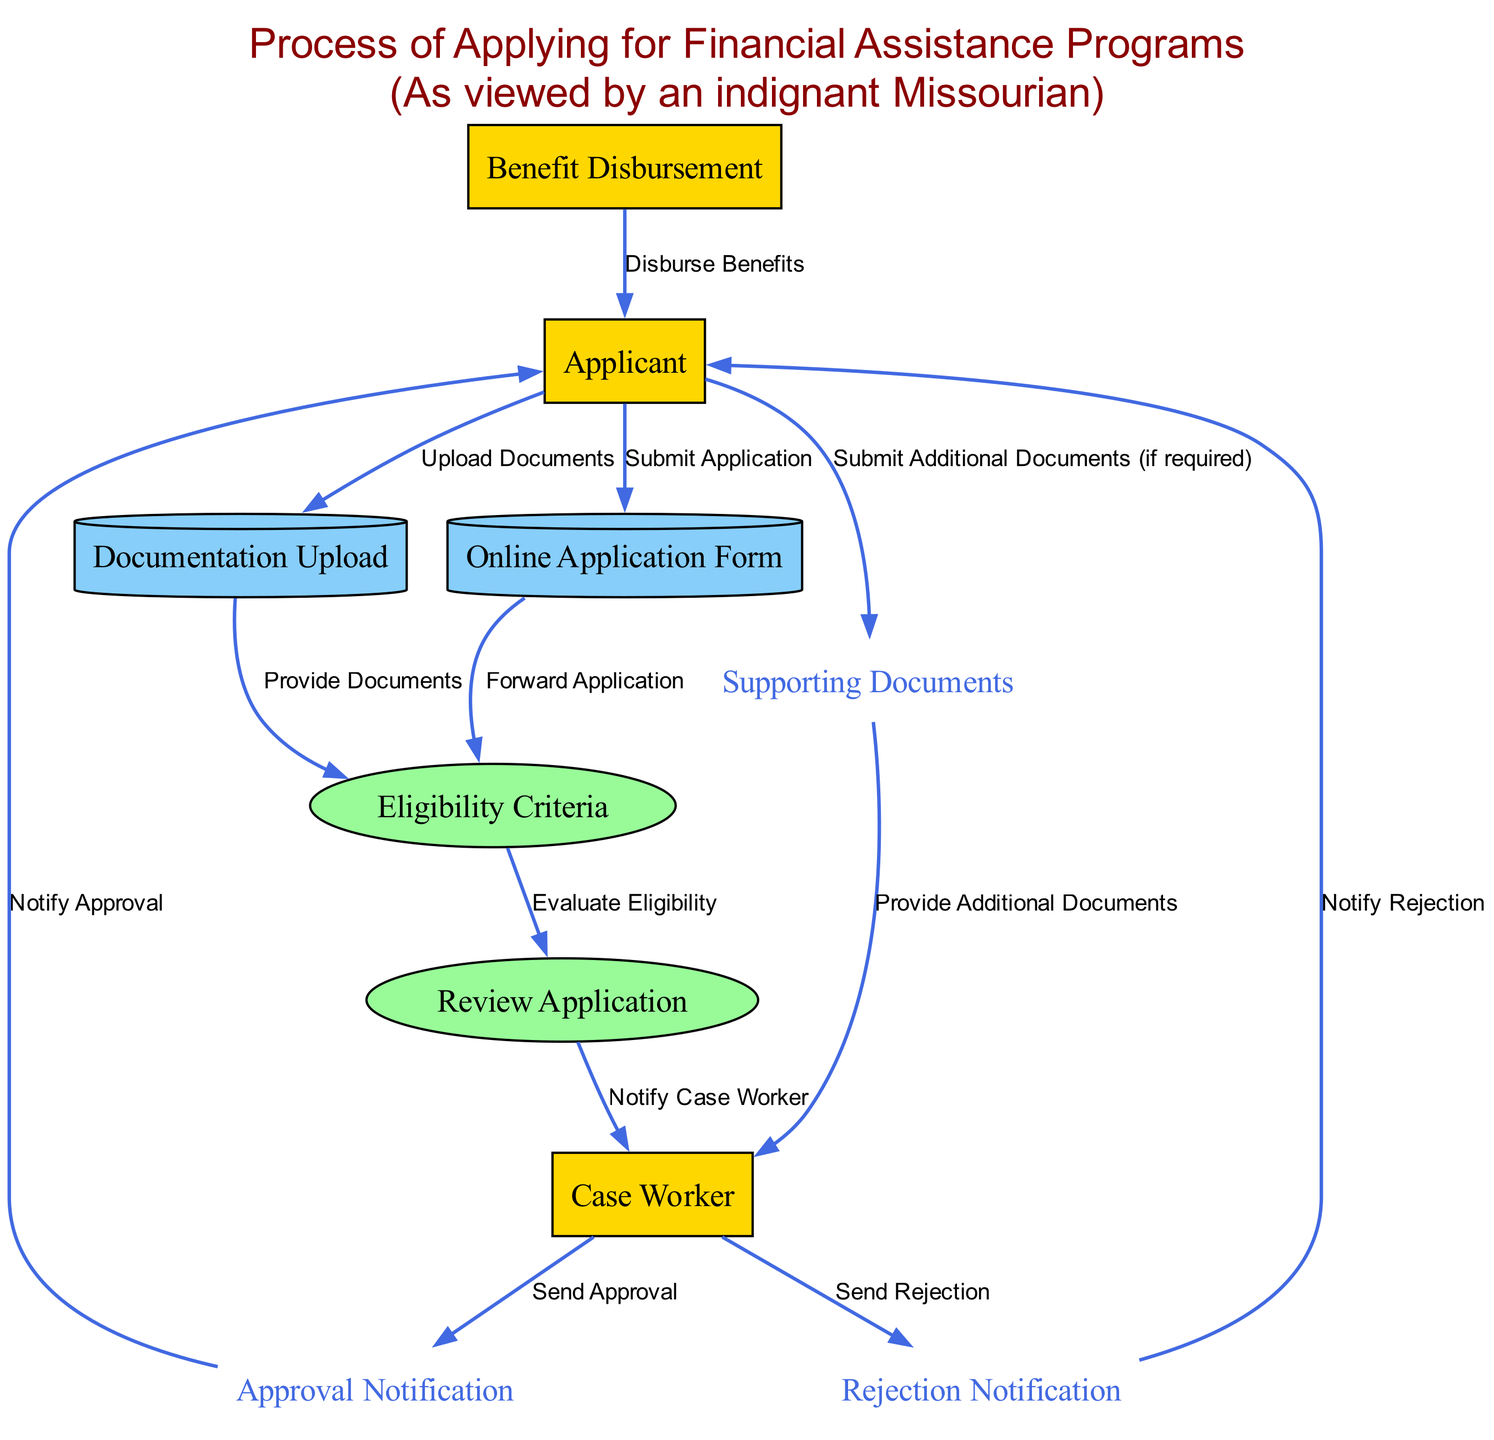What is the first action taken by the Applicant? The Applicant's first action is to submit their application, which is shown by the data flow from the Applicant to the Online Application Form labeled "Submit Application."
Answer: Submit Application How many external entities are present in the diagram? The diagram includes three external entities: the Applicant, Case Worker, and Benefit Disbursement. By counting these entities, we find the total is three.
Answer: Three What do the Approval Notification and Rejection Notification represent? Both the Approval Notification and Rejection Notification represent data flows that convey the results of the application review process to the Applicant from the Case Worker.
Answer: Data flows After eligibility is evaluated, what is the next step? After eligibility is evaluated, the next step is to review the application, represented by the data flow from Eligibility Criteria to Review Application labeled "Evaluate Eligibility."
Answer: Review Application Which entity receives the "Disburse Benefits" notification? The entity that receives the "Disburse Benefits" notification is the Applicant, as indicated by the data flow leading from Benefit Disbursement to Applicant labeled "Disburse Benefits."
Answer: Applicant What triggers the Case Worker to send an Approval? The Case Worker sends an Approval after being notified by the Review Application process, which evaluates the application and tells the Case Worker to communicate the approval.
Answer: Review Application How many data stores are shown in the diagram? The diagram includes two data stores: the Online Application Form and Documentation Upload. Therefore, if we count these, the total number is two.
Answer: Two What happens if the Applicant needs to submit more documents? If the Applicant needs to submit more documents, they submit additional documents labeled "Submit Additional Documents (if required)" which are then provided to the Case Worker as indicated by the flow from Supporting Documents.
Answer: Submit Additional Documents 